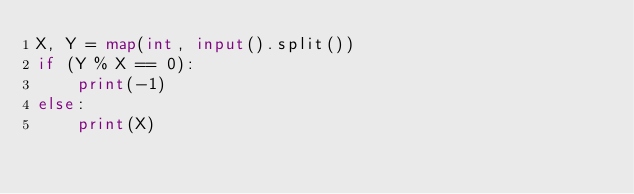<code> <loc_0><loc_0><loc_500><loc_500><_Python_>X, Y = map(int, input().split())
if (Y % X == 0):
    print(-1)
else:
    print(X)
</code> 